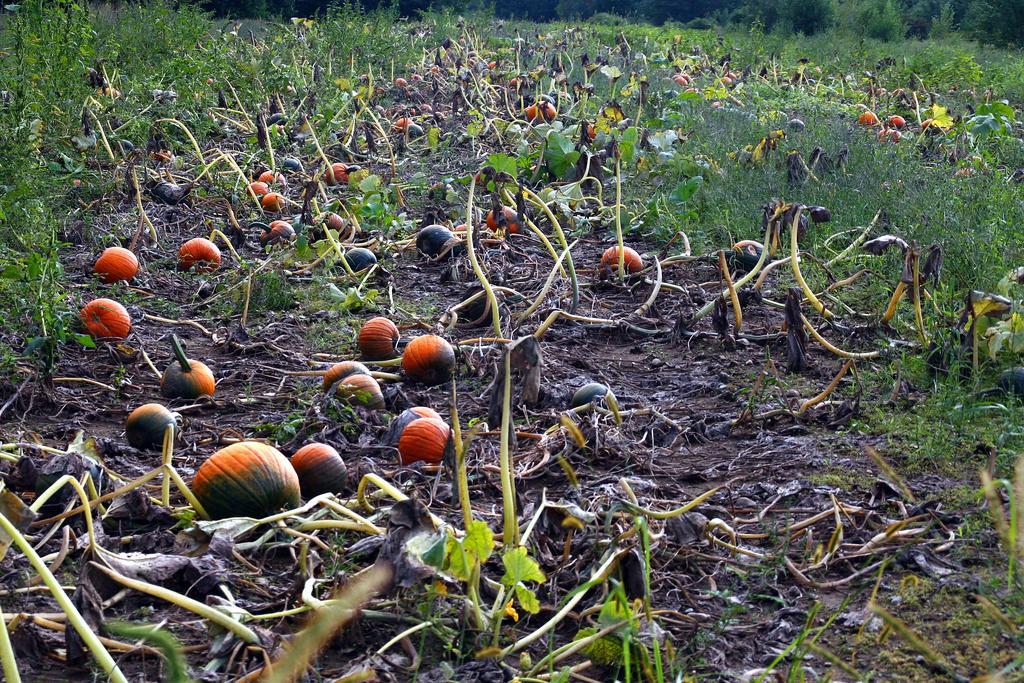Describe this image in one or two sentences. In this image we can see pumpkins and grass on the ground. 